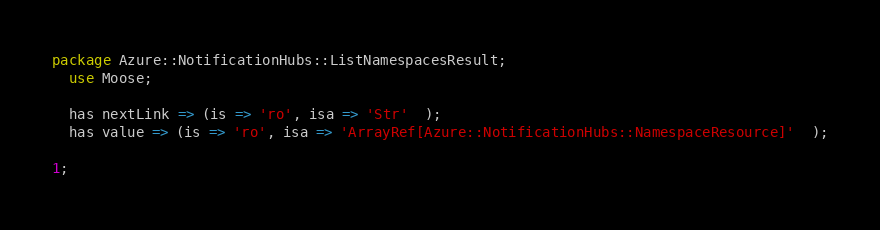<code> <loc_0><loc_0><loc_500><loc_500><_Perl_>package Azure::NotificationHubs::ListNamespacesResult;
  use Moose;

  has nextLink => (is => 'ro', isa => 'Str'  );
  has value => (is => 'ro', isa => 'ArrayRef[Azure::NotificationHubs::NamespaceResource]'  );

1;
</code> 